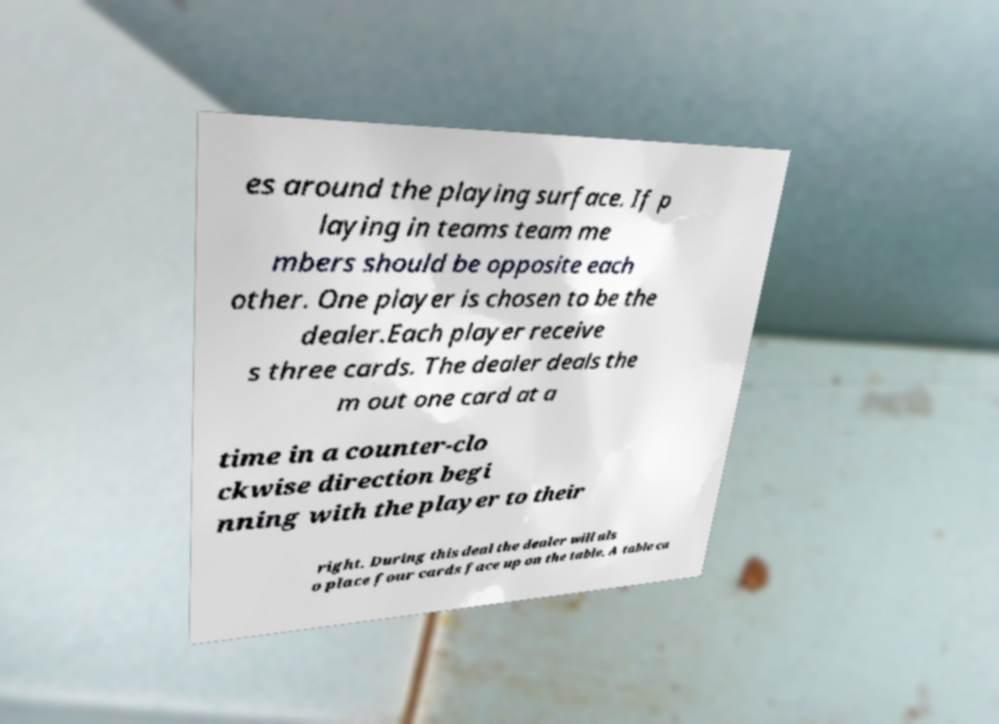Could you extract and type out the text from this image? es around the playing surface. If p laying in teams team me mbers should be opposite each other. One player is chosen to be the dealer.Each player receive s three cards. The dealer deals the m out one card at a time in a counter-clo ckwise direction begi nning with the player to their right. During this deal the dealer will als o place four cards face up on the table. A table ca 